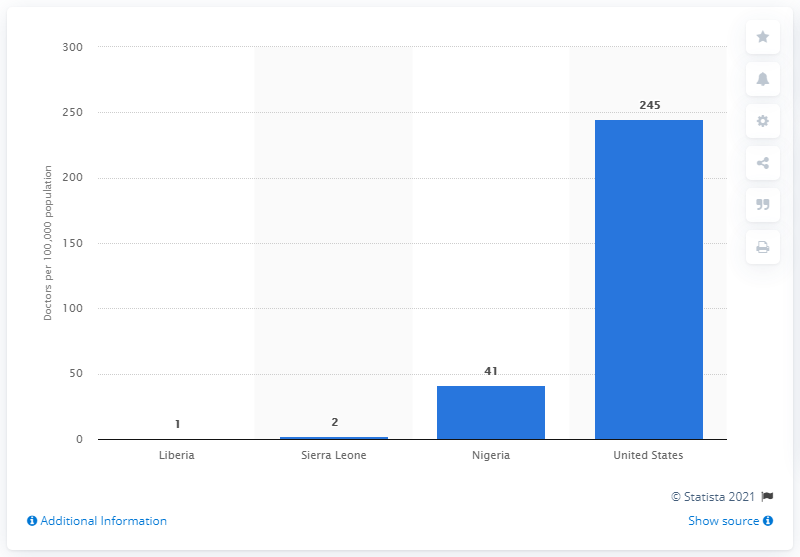Highlight a few significant elements in this photo. In Sierra Leone, there are approximately 2 doctors for every 100,000 people. According to data, the United States has approximately 245 doctors per 100,000 of its population. 